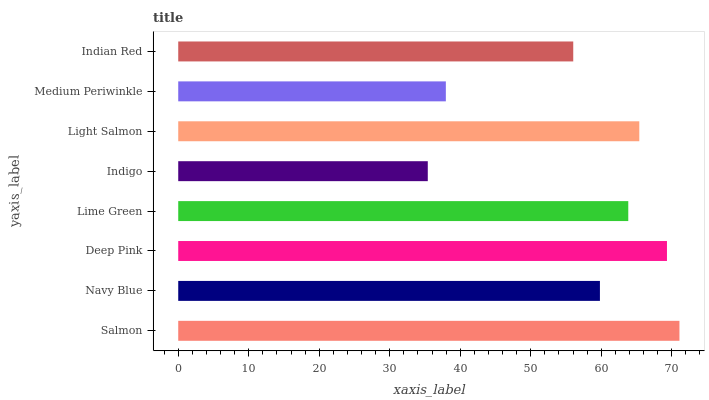Is Indigo the minimum?
Answer yes or no. Yes. Is Salmon the maximum?
Answer yes or no. Yes. Is Navy Blue the minimum?
Answer yes or no. No. Is Navy Blue the maximum?
Answer yes or no. No. Is Salmon greater than Navy Blue?
Answer yes or no. Yes. Is Navy Blue less than Salmon?
Answer yes or no. Yes. Is Navy Blue greater than Salmon?
Answer yes or no. No. Is Salmon less than Navy Blue?
Answer yes or no. No. Is Lime Green the high median?
Answer yes or no. Yes. Is Navy Blue the low median?
Answer yes or no. Yes. Is Indigo the high median?
Answer yes or no. No. Is Indian Red the low median?
Answer yes or no. No. 